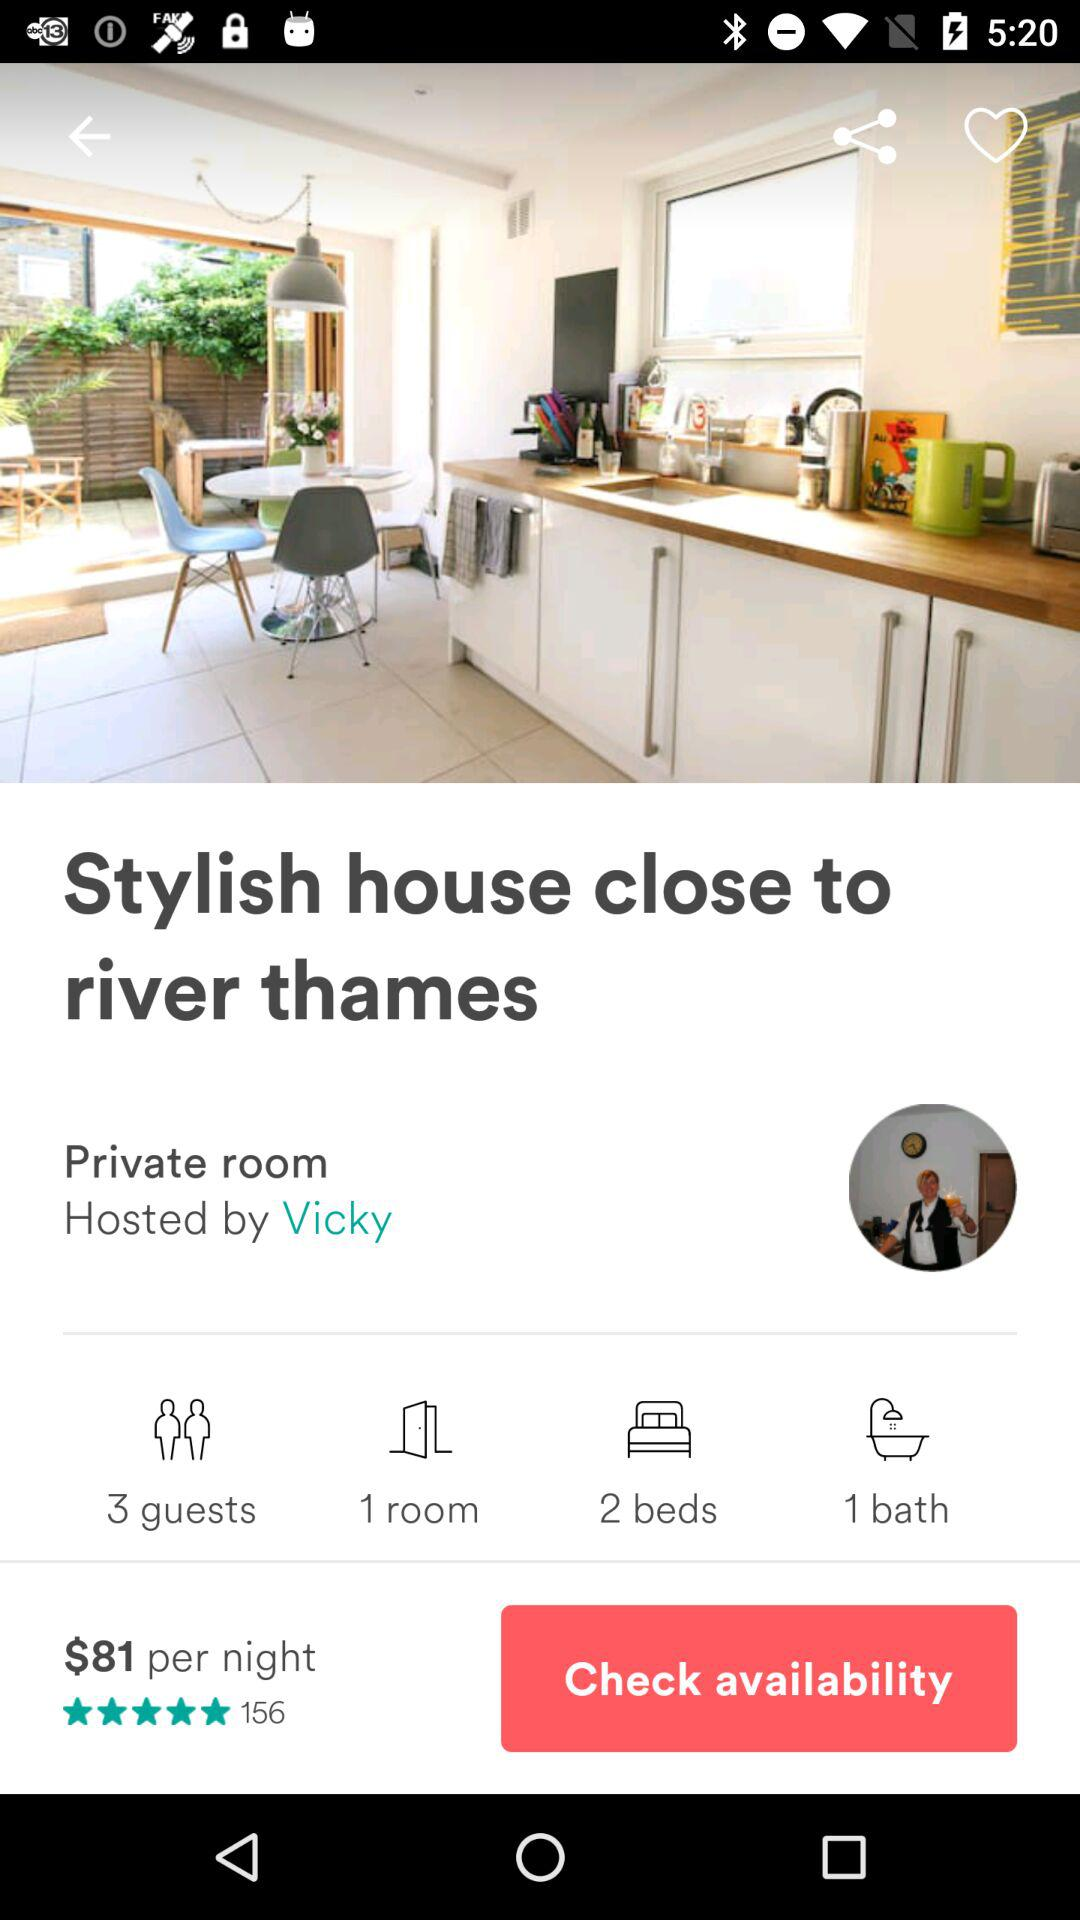What is the number of beds? The number of beds is 2. 